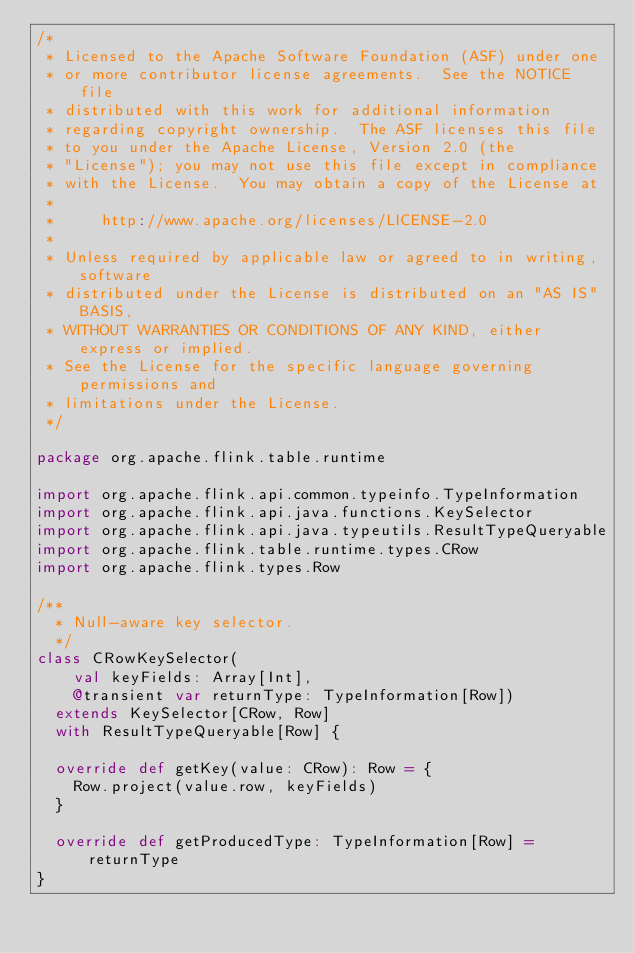Convert code to text. <code><loc_0><loc_0><loc_500><loc_500><_Scala_>/*
 * Licensed to the Apache Software Foundation (ASF) under one
 * or more contributor license agreements.  See the NOTICE file
 * distributed with this work for additional information
 * regarding copyright ownership.  The ASF licenses this file
 * to you under the Apache License, Version 2.0 (the
 * "License"); you may not use this file except in compliance
 * with the License.  You may obtain a copy of the License at
 *
 *     http://www.apache.org/licenses/LICENSE-2.0
 *
 * Unless required by applicable law or agreed to in writing, software
 * distributed under the License is distributed on an "AS IS" BASIS,
 * WITHOUT WARRANTIES OR CONDITIONS OF ANY KIND, either express or implied.
 * See the License for the specific language governing permissions and
 * limitations under the License.
 */

package org.apache.flink.table.runtime

import org.apache.flink.api.common.typeinfo.TypeInformation
import org.apache.flink.api.java.functions.KeySelector
import org.apache.flink.api.java.typeutils.ResultTypeQueryable
import org.apache.flink.table.runtime.types.CRow
import org.apache.flink.types.Row

/**
  * Null-aware key selector.
  */
class CRowKeySelector(
    val keyFields: Array[Int],
    @transient var returnType: TypeInformation[Row])
  extends KeySelector[CRow, Row]
  with ResultTypeQueryable[Row] {

  override def getKey(value: CRow): Row = {
    Row.project(value.row, keyFields)
  }

  override def getProducedType: TypeInformation[Row] = returnType
}
</code> 